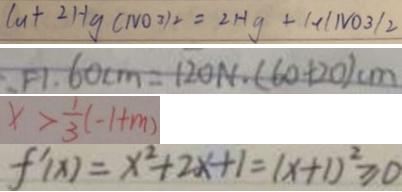Convert formula to latex. <formula><loc_0><loc_0><loc_500><loc_500>C u + 2 H g ( N O 3 ) _ { 2 } = 2 H g + 1 + l N O _ { 3 } / 2 
 F 1 . 6 0 c m = 1 2 0 N . ( 6 0 + 2 0 ) c m 
 x > \frac { 1 } { 3 } ( - 1 + m ) 
 f ^ { \prime } ( x ) = x ^ { 2 } + 2 x + 1 = ( x + 1 ) ^ { 2 } \geq 0</formula> 